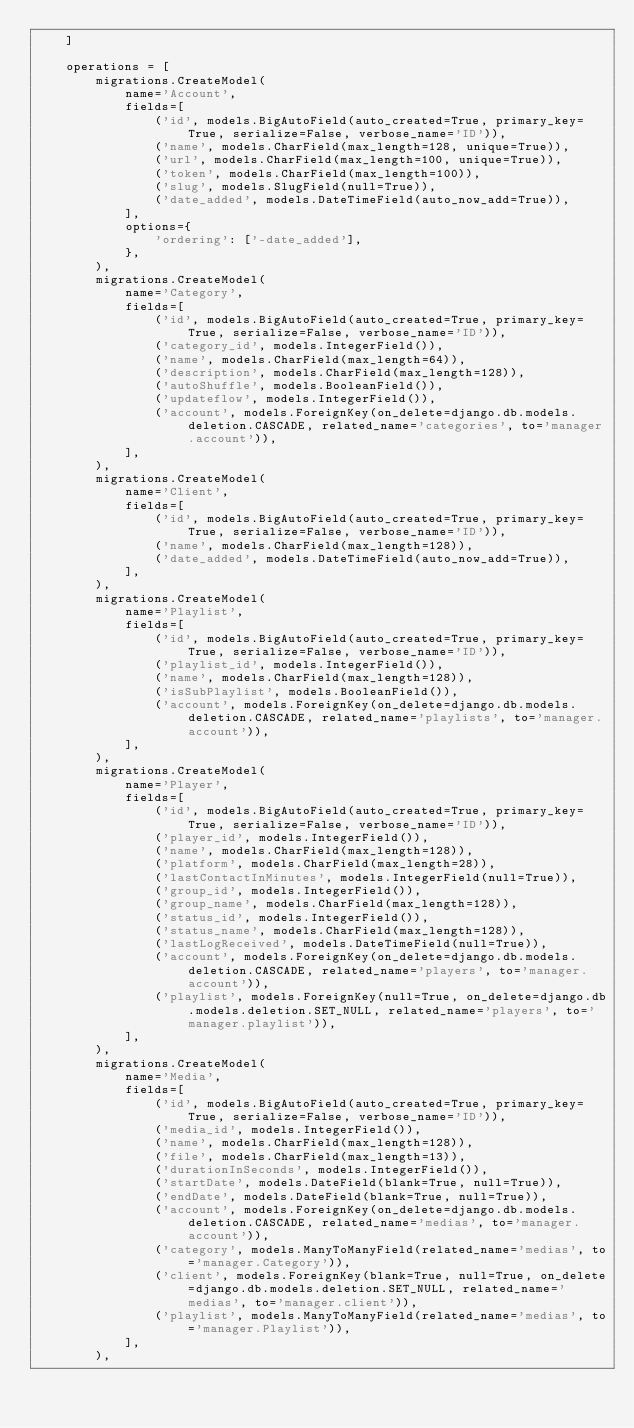<code> <loc_0><loc_0><loc_500><loc_500><_Python_>    ]

    operations = [
        migrations.CreateModel(
            name='Account',
            fields=[
                ('id', models.BigAutoField(auto_created=True, primary_key=True, serialize=False, verbose_name='ID')),
                ('name', models.CharField(max_length=128, unique=True)),
                ('url', models.CharField(max_length=100, unique=True)),
                ('token', models.CharField(max_length=100)),
                ('slug', models.SlugField(null=True)),
                ('date_added', models.DateTimeField(auto_now_add=True)),
            ],
            options={
                'ordering': ['-date_added'],
            },
        ),
        migrations.CreateModel(
            name='Category',
            fields=[
                ('id', models.BigAutoField(auto_created=True, primary_key=True, serialize=False, verbose_name='ID')),
                ('category_id', models.IntegerField()),
                ('name', models.CharField(max_length=64)),
                ('description', models.CharField(max_length=128)),
                ('autoShuffle', models.BooleanField()),
                ('updateflow', models.IntegerField()),
                ('account', models.ForeignKey(on_delete=django.db.models.deletion.CASCADE, related_name='categories', to='manager.account')),
            ],
        ),
        migrations.CreateModel(
            name='Client',
            fields=[
                ('id', models.BigAutoField(auto_created=True, primary_key=True, serialize=False, verbose_name='ID')),
                ('name', models.CharField(max_length=128)),
                ('date_added', models.DateTimeField(auto_now_add=True)),
            ],
        ),
        migrations.CreateModel(
            name='Playlist',
            fields=[
                ('id', models.BigAutoField(auto_created=True, primary_key=True, serialize=False, verbose_name='ID')),
                ('playlist_id', models.IntegerField()),
                ('name', models.CharField(max_length=128)),
                ('isSubPlaylist', models.BooleanField()),
                ('account', models.ForeignKey(on_delete=django.db.models.deletion.CASCADE, related_name='playlists', to='manager.account')),
            ],
        ),
        migrations.CreateModel(
            name='Player',
            fields=[
                ('id', models.BigAutoField(auto_created=True, primary_key=True, serialize=False, verbose_name='ID')),
                ('player_id', models.IntegerField()),
                ('name', models.CharField(max_length=128)),
                ('platform', models.CharField(max_length=28)),
                ('lastContactInMinutes', models.IntegerField(null=True)),
                ('group_id', models.IntegerField()),
                ('group_name', models.CharField(max_length=128)),
                ('status_id', models.IntegerField()),
                ('status_name', models.CharField(max_length=128)),
                ('lastLogReceived', models.DateTimeField(null=True)),
                ('account', models.ForeignKey(on_delete=django.db.models.deletion.CASCADE, related_name='players', to='manager.account')),
                ('playlist', models.ForeignKey(null=True, on_delete=django.db.models.deletion.SET_NULL, related_name='players', to='manager.playlist')),
            ],
        ),
        migrations.CreateModel(
            name='Media',
            fields=[
                ('id', models.BigAutoField(auto_created=True, primary_key=True, serialize=False, verbose_name='ID')),
                ('media_id', models.IntegerField()),
                ('name', models.CharField(max_length=128)),
                ('file', models.CharField(max_length=13)),
                ('durationInSeconds', models.IntegerField()),
                ('startDate', models.DateField(blank=True, null=True)),
                ('endDate', models.DateField(blank=True, null=True)),
                ('account', models.ForeignKey(on_delete=django.db.models.deletion.CASCADE, related_name='medias', to='manager.account')),
                ('category', models.ManyToManyField(related_name='medias', to='manager.Category')),
                ('client', models.ForeignKey(blank=True, null=True, on_delete=django.db.models.deletion.SET_NULL, related_name='medias', to='manager.client')),
                ('playlist', models.ManyToManyField(related_name='medias', to='manager.Playlist')),
            ],
        ),</code> 